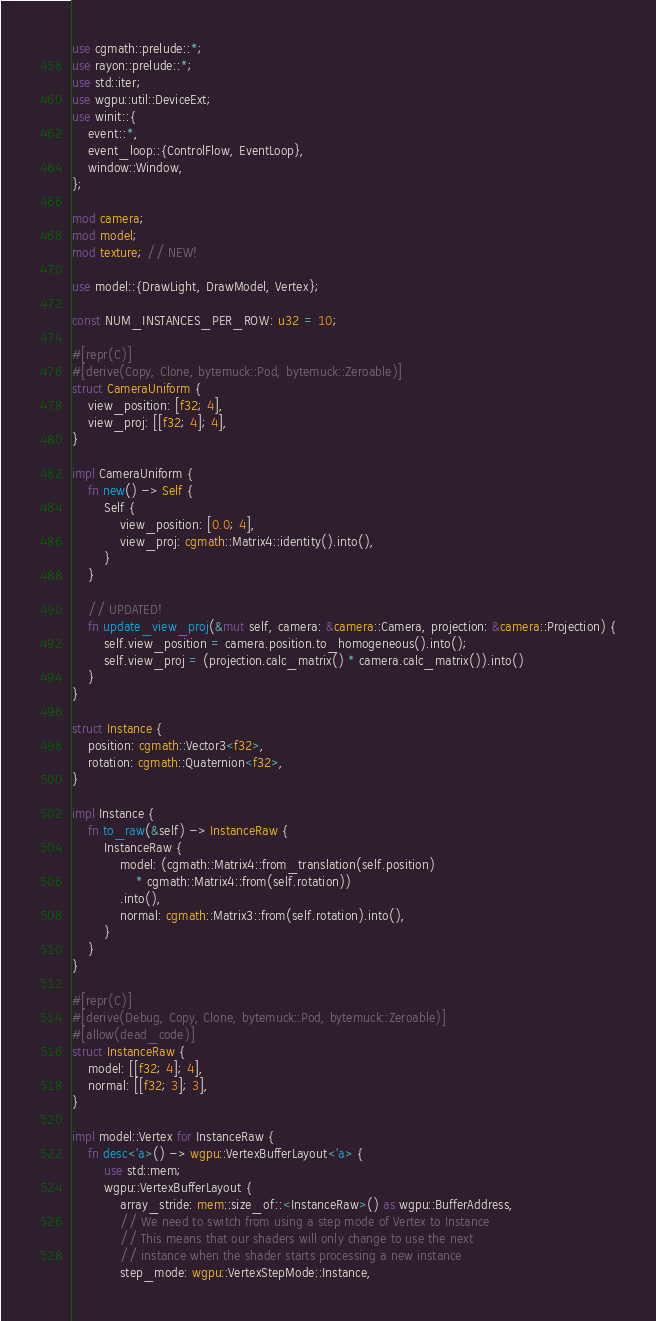Convert code to text. <code><loc_0><loc_0><loc_500><loc_500><_Rust_>use cgmath::prelude::*;
use rayon::prelude::*;
use std::iter;
use wgpu::util::DeviceExt;
use winit::{
    event::*,
    event_loop::{ControlFlow, EventLoop},
    window::Window,
};

mod camera;
mod model;
mod texture; // NEW!

use model::{DrawLight, DrawModel, Vertex};

const NUM_INSTANCES_PER_ROW: u32 = 10;

#[repr(C)]
#[derive(Copy, Clone, bytemuck::Pod, bytemuck::Zeroable)]
struct CameraUniform {
    view_position: [f32; 4],
    view_proj: [[f32; 4]; 4],
}

impl CameraUniform {
    fn new() -> Self {
        Self {
            view_position: [0.0; 4],
            view_proj: cgmath::Matrix4::identity().into(),
        }
    }

    // UPDATED!
    fn update_view_proj(&mut self, camera: &camera::Camera, projection: &camera::Projection) {
        self.view_position = camera.position.to_homogeneous().into();
        self.view_proj = (projection.calc_matrix() * camera.calc_matrix()).into()
    }
}

struct Instance {
    position: cgmath::Vector3<f32>,
    rotation: cgmath::Quaternion<f32>,
}

impl Instance {
    fn to_raw(&self) -> InstanceRaw {
        InstanceRaw {
            model: (cgmath::Matrix4::from_translation(self.position)
                * cgmath::Matrix4::from(self.rotation))
            .into(),
            normal: cgmath::Matrix3::from(self.rotation).into(),
        }
    }
}

#[repr(C)]
#[derive(Debug, Copy, Clone, bytemuck::Pod, bytemuck::Zeroable)]
#[allow(dead_code)]
struct InstanceRaw {
    model: [[f32; 4]; 4],
    normal: [[f32; 3]; 3],
}

impl model::Vertex for InstanceRaw {
    fn desc<'a>() -> wgpu::VertexBufferLayout<'a> {
        use std::mem;
        wgpu::VertexBufferLayout {
            array_stride: mem::size_of::<InstanceRaw>() as wgpu::BufferAddress,
            // We need to switch from using a step mode of Vertex to Instance
            // This means that our shaders will only change to use the next
            // instance when the shader starts processing a new instance
            step_mode: wgpu::VertexStepMode::Instance,</code> 